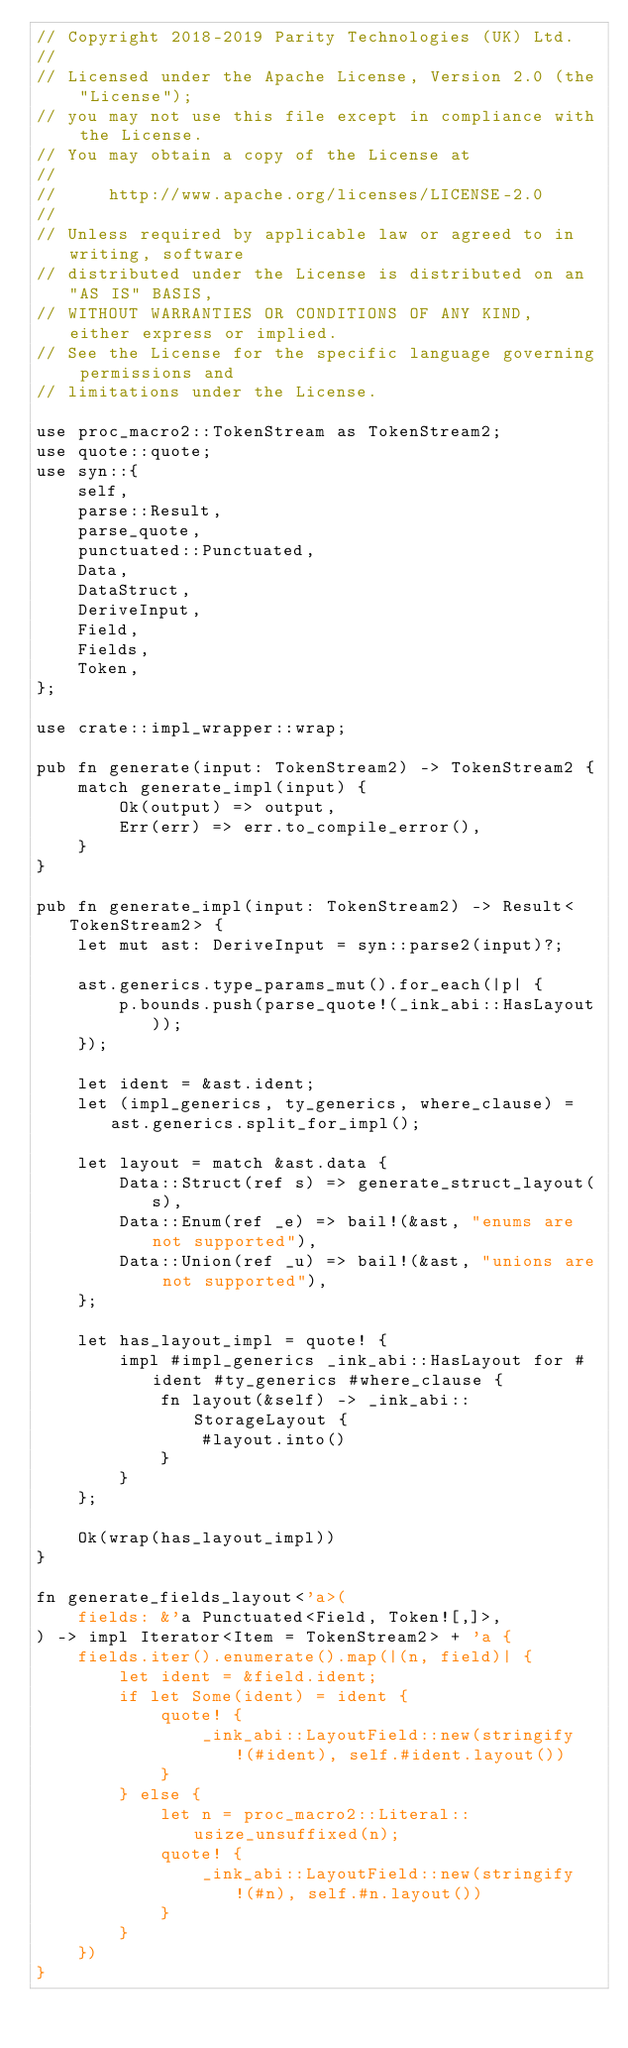<code> <loc_0><loc_0><loc_500><loc_500><_Rust_>// Copyright 2018-2019 Parity Technologies (UK) Ltd.
//
// Licensed under the Apache License, Version 2.0 (the "License");
// you may not use this file except in compliance with the License.
// You may obtain a copy of the License at
//
//     http://www.apache.org/licenses/LICENSE-2.0
//
// Unless required by applicable law or agreed to in writing, software
// distributed under the License is distributed on an "AS IS" BASIS,
// WITHOUT WARRANTIES OR CONDITIONS OF ANY KIND, either express or implied.
// See the License for the specific language governing permissions and
// limitations under the License.

use proc_macro2::TokenStream as TokenStream2;
use quote::quote;
use syn::{
    self,
    parse::Result,
    parse_quote,
    punctuated::Punctuated,
    Data,
    DataStruct,
    DeriveInput,
    Field,
    Fields,
    Token,
};

use crate::impl_wrapper::wrap;

pub fn generate(input: TokenStream2) -> TokenStream2 {
    match generate_impl(input) {
        Ok(output) => output,
        Err(err) => err.to_compile_error(),
    }
}

pub fn generate_impl(input: TokenStream2) -> Result<TokenStream2> {
    let mut ast: DeriveInput = syn::parse2(input)?;

    ast.generics.type_params_mut().for_each(|p| {
        p.bounds.push(parse_quote!(_ink_abi::HasLayout));
    });

    let ident = &ast.ident;
    let (impl_generics, ty_generics, where_clause) = ast.generics.split_for_impl();

    let layout = match &ast.data {
        Data::Struct(ref s) => generate_struct_layout(s),
        Data::Enum(ref _e) => bail!(&ast, "enums are not supported"),
        Data::Union(ref _u) => bail!(&ast, "unions are not supported"),
    };

    let has_layout_impl = quote! {
        impl #impl_generics _ink_abi::HasLayout for #ident #ty_generics #where_clause {
            fn layout(&self) -> _ink_abi::StorageLayout {
                #layout.into()
            }
        }
    };

    Ok(wrap(has_layout_impl))
}

fn generate_fields_layout<'a>(
    fields: &'a Punctuated<Field, Token![,]>,
) -> impl Iterator<Item = TokenStream2> + 'a {
    fields.iter().enumerate().map(|(n, field)| {
        let ident = &field.ident;
        if let Some(ident) = ident {
            quote! {
                _ink_abi::LayoutField::new(stringify!(#ident), self.#ident.layout())
            }
        } else {
            let n = proc_macro2::Literal::usize_unsuffixed(n);
            quote! {
                _ink_abi::LayoutField::new(stringify!(#n), self.#n.layout())
            }
        }
    })
}
</code> 